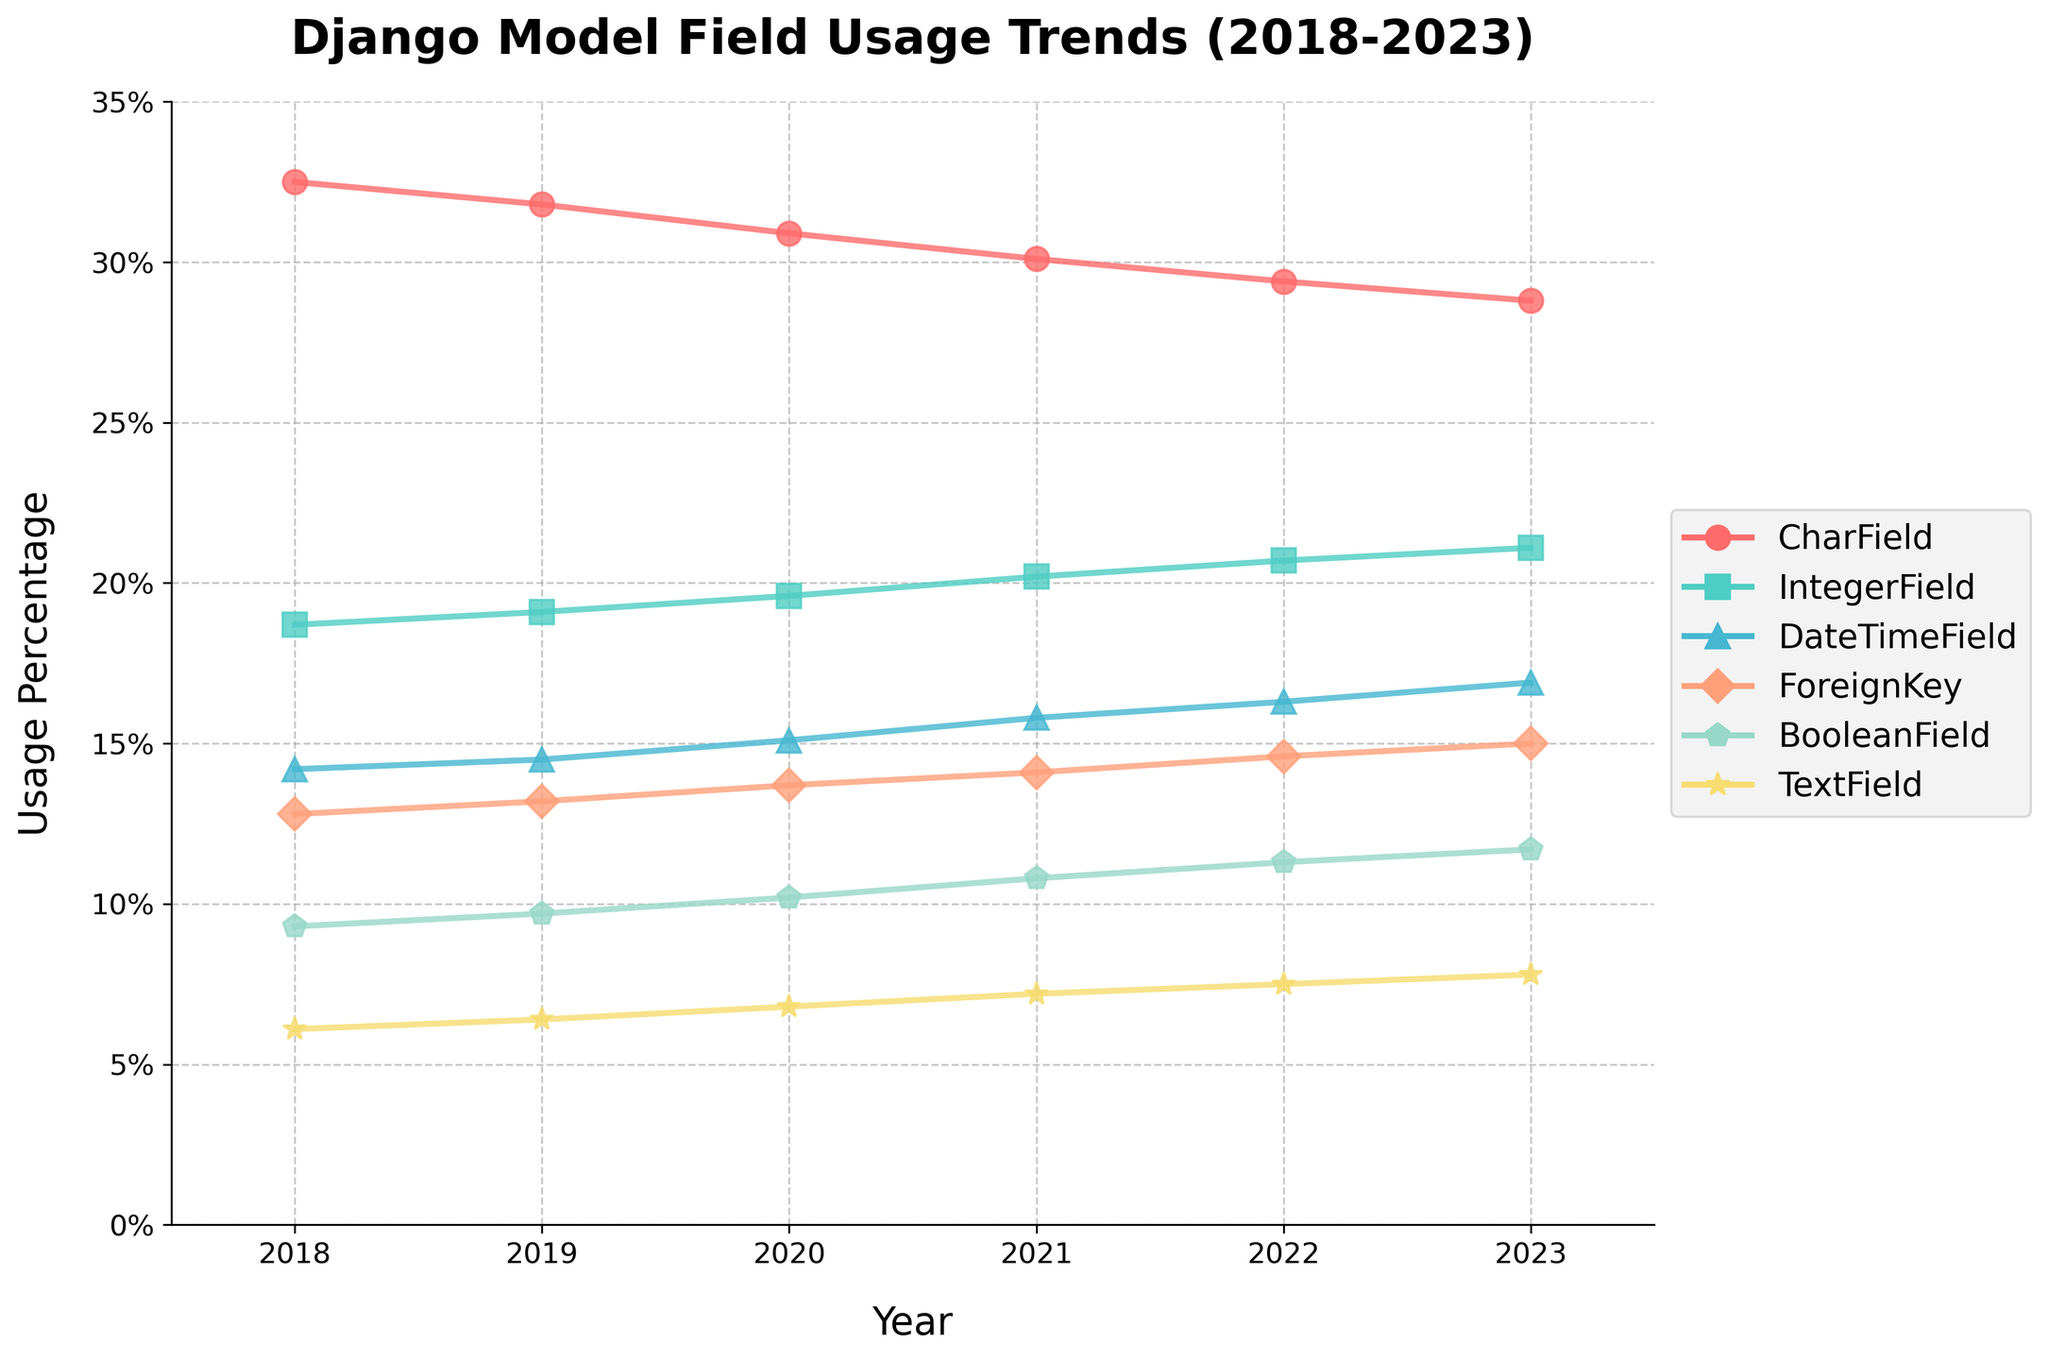What is the trend of CharField usage over the years? The usage percentage of CharField decreases gradually from 32.5% in 2018 to 28.8% in 2023. Each year shows a slight decline.
Answer: Decreasing Which year had the highest usage of IntegerField? By examining the peaks in the IntegerField line, the highest point is at 21.1% in the year 2023.
Answer: 2023 How does the usage of DateTimeField in 2023 compare to its usage in 2018? The usage of DateTimeField in 2023 is 16.9%, while in 2018, it was 14.2%. This shows an increase of 2.7%.
Answer: Higher in 2023 What's the average percentage usage of BooleanField from 2018 to 2023? Sum the usage percentages of BooleanField from 2018 to 2023: 9.3 + 9.7 + 10.2 + 10.8 + 11.3 + 11.7 = 63. Dividing by 6 (number of years) yields an average of 63/6.
Answer: 10.5% How did the usage of TextField change from 2018 to 2023? The usage of TextField increased steadily from 6.1% in 2018 to 7.8% in 2023, showing a total increase of 1.7%.
Answer: Increased Which field type shows the most consistent trend over the period? Both CharField and TextField lines show consistent trends. CharField has a consistent downward trend while TextField has a consistent upward trend.
Answer: CharField and TextField What is the total usage percentage of ForeignKey in 2021 and 2022 combined? Adding the values of ForeignKey for 2021 (14.1%) and 2022 (14.6%) results in a total usage of 28.7%.
Answer: 28.7% Considering 2020, which field type seems to spike the most from the previous year? Comparing the values from 2019 to 2020, DateTimeField usage jumps from 14.5% to 15.1%, an increase of 0.6%, which is noticeable among other fields.
Answer: DateTimeField Identify the fields that have a usage percentage above 15% in 2023. In 2023, CharField (28.8%), IntegerField (21.1%), DateTimeField (16.9%), and ForeignKey (15%) all have usage percentages above 15%.
Answer: CharField, IntegerField, DateTimeField, ForeignKey What is the visual attribute (color) used to represent BooleanField in the plot? Observing the colors assigned to each field, BooleanField is represented in green.
Answer: Green 